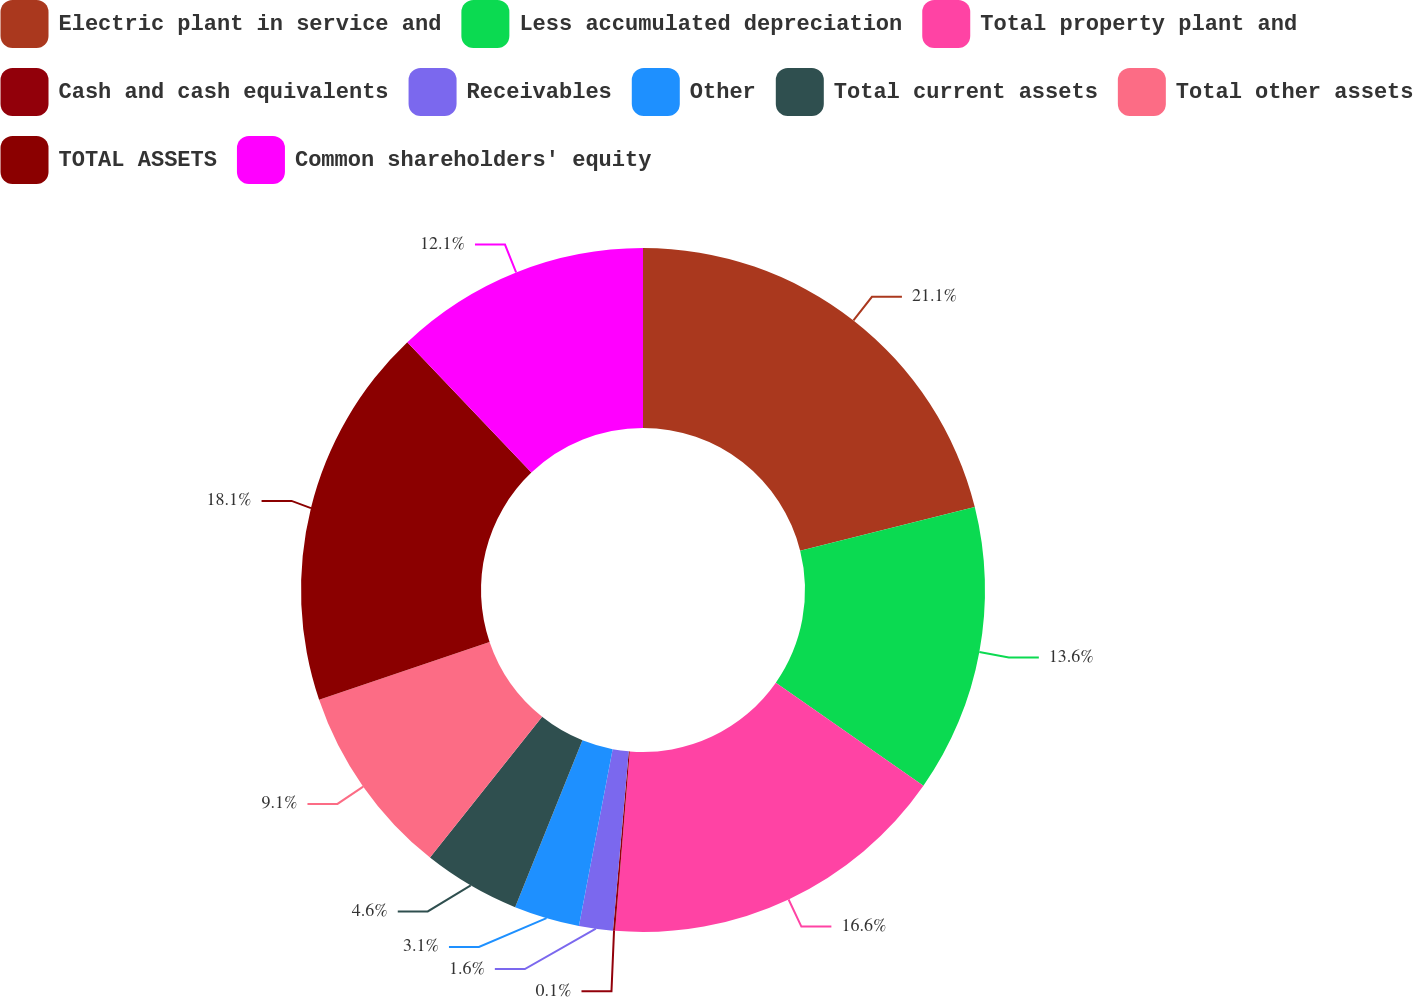Convert chart. <chart><loc_0><loc_0><loc_500><loc_500><pie_chart><fcel>Electric plant in service and<fcel>Less accumulated depreciation<fcel>Total property plant and<fcel>Cash and cash equivalents<fcel>Receivables<fcel>Other<fcel>Total current assets<fcel>Total other assets<fcel>TOTAL ASSETS<fcel>Common shareholders' equity<nl><fcel>21.1%<fcel>13.6%<fcel>16.6%<fcel>0.1%<fcel>1.6%<fcel>3.1%<fcel>4.6%<fcel>9.1%<fcel>18.1%<fcel>12.1%<nl></chart> 